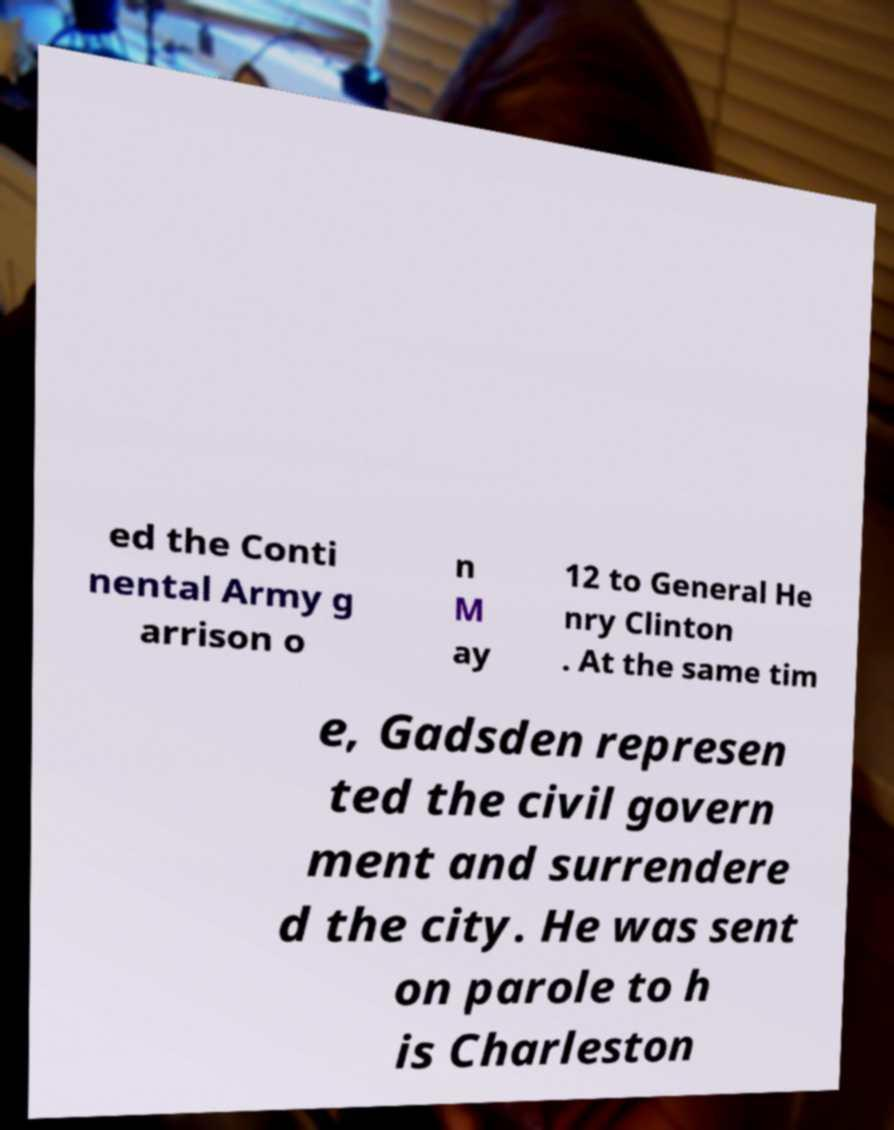I need the written content from this picture converted into text. Can you do that? ed the Conti nental Army g arrison o n M ay 12 to General He nry Clinton . At the same tim e, Gadsden represen ted the civil govern ment and surrendere d the city. He was sent on parole to h is Charleston 